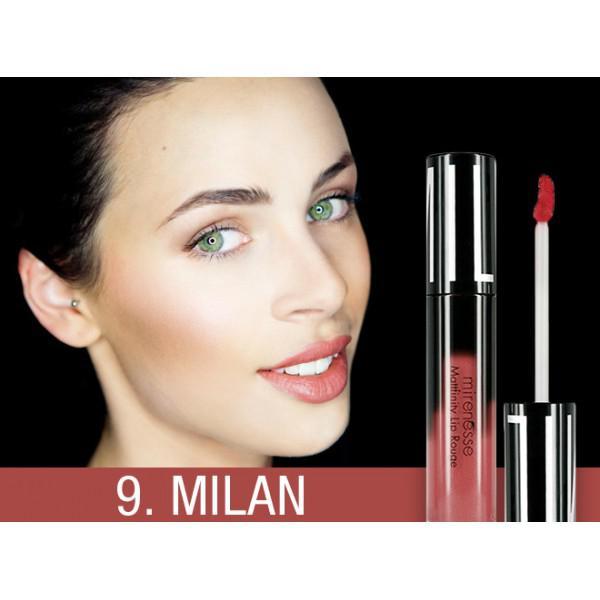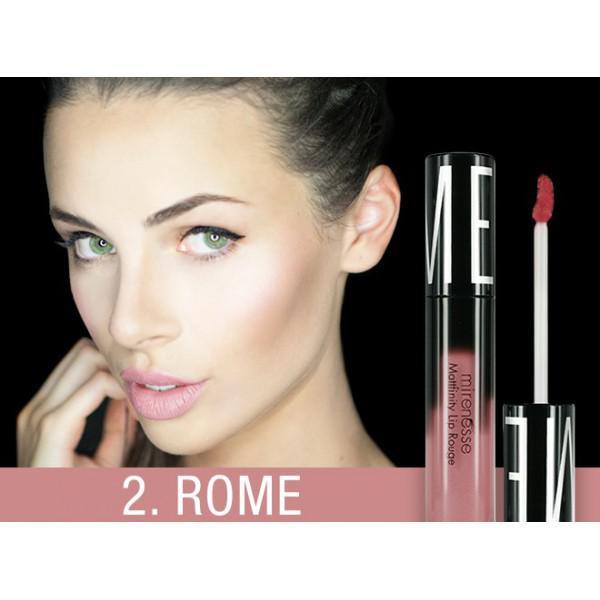The first image is the image on the left, the second image is the image on the right. Assess this claim about the two images: "There is exactly one hand visible in one of the images". Correct or not? Answer yes or no. Yes. The first image is the image on the left, the second image is the image on the right. For the images shown, is this caption "Both images show models with non-pursed open mouths with no tongue showing." true? Answer yes or no. Yes. 